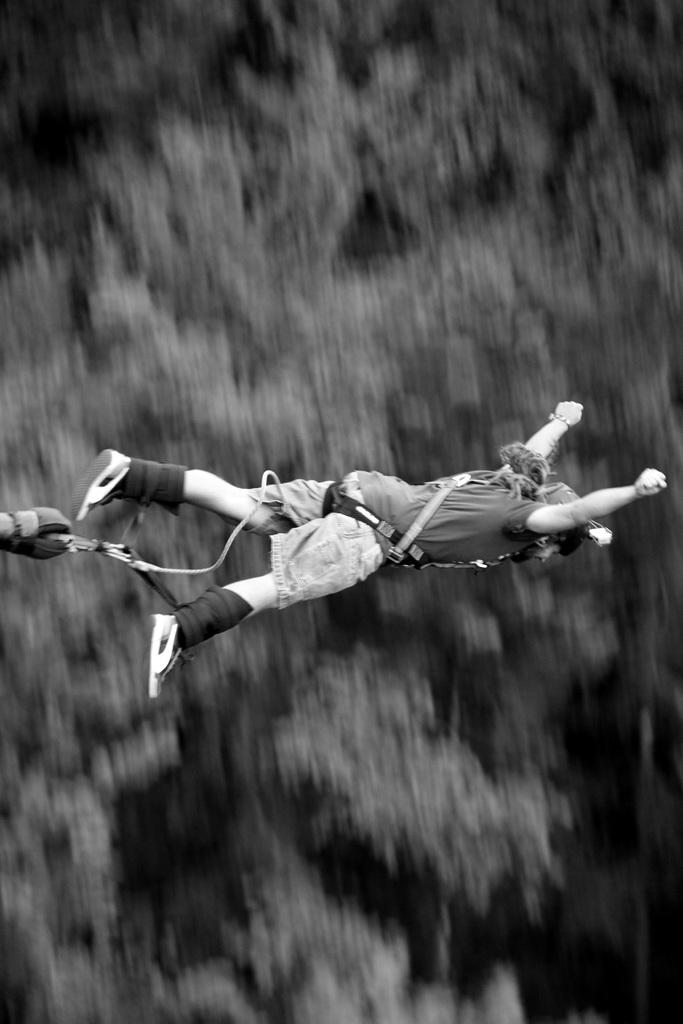What is the color scheme of the image? The image is black and white. What is the person in the image doing? The person is flying in the sky in the image. What can be seen attached to the person's body? The person has belts tied to their body. What type of whistle can be heard in the image? There is no whistle present in the image, as it is a visual representation and does not contain any sounds. 